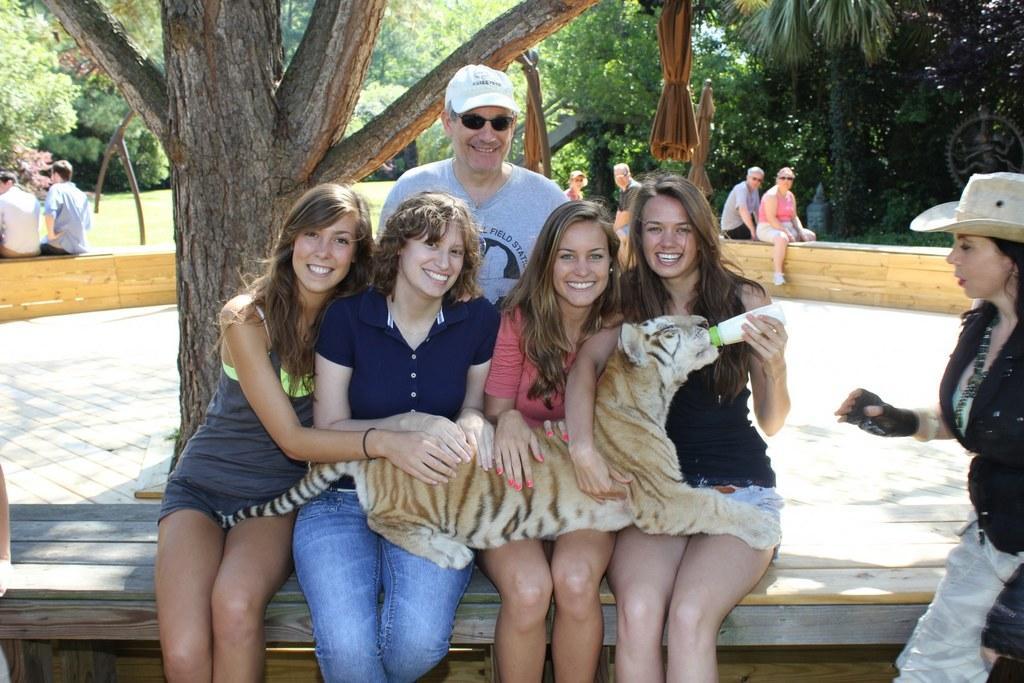How would you summarize this image in a sentence or two? In the middle of the image few women are sitting and holding a tiger and smiling. Behind them a man is sitting and smiling. Bottom right side of the image a woman is standing and watching. Top left side of the image there are some trees. Behind the trees few people are sitting. 